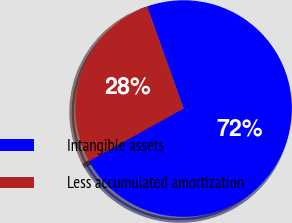Convert chart. <chart><loc_0><loc_0><loc_500><loc_500><pie_chart><fcel>Intangible assets<fcel>Less accumulated amortization<nl><fcel>72.38%<fcel>27.62%<nl></chart> 